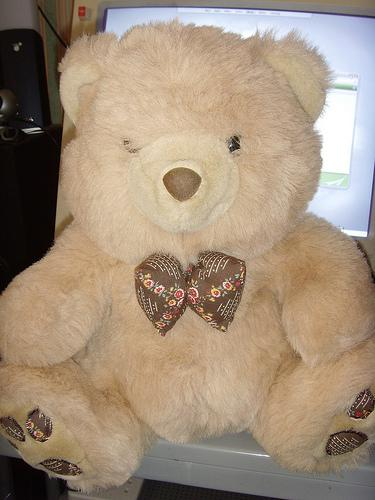Question: what does the bear have on?
Choices:
A. A hat.
B. A tie.
C. A bow tie.
D. A shirt.
Answer with the letter. Answer: C 